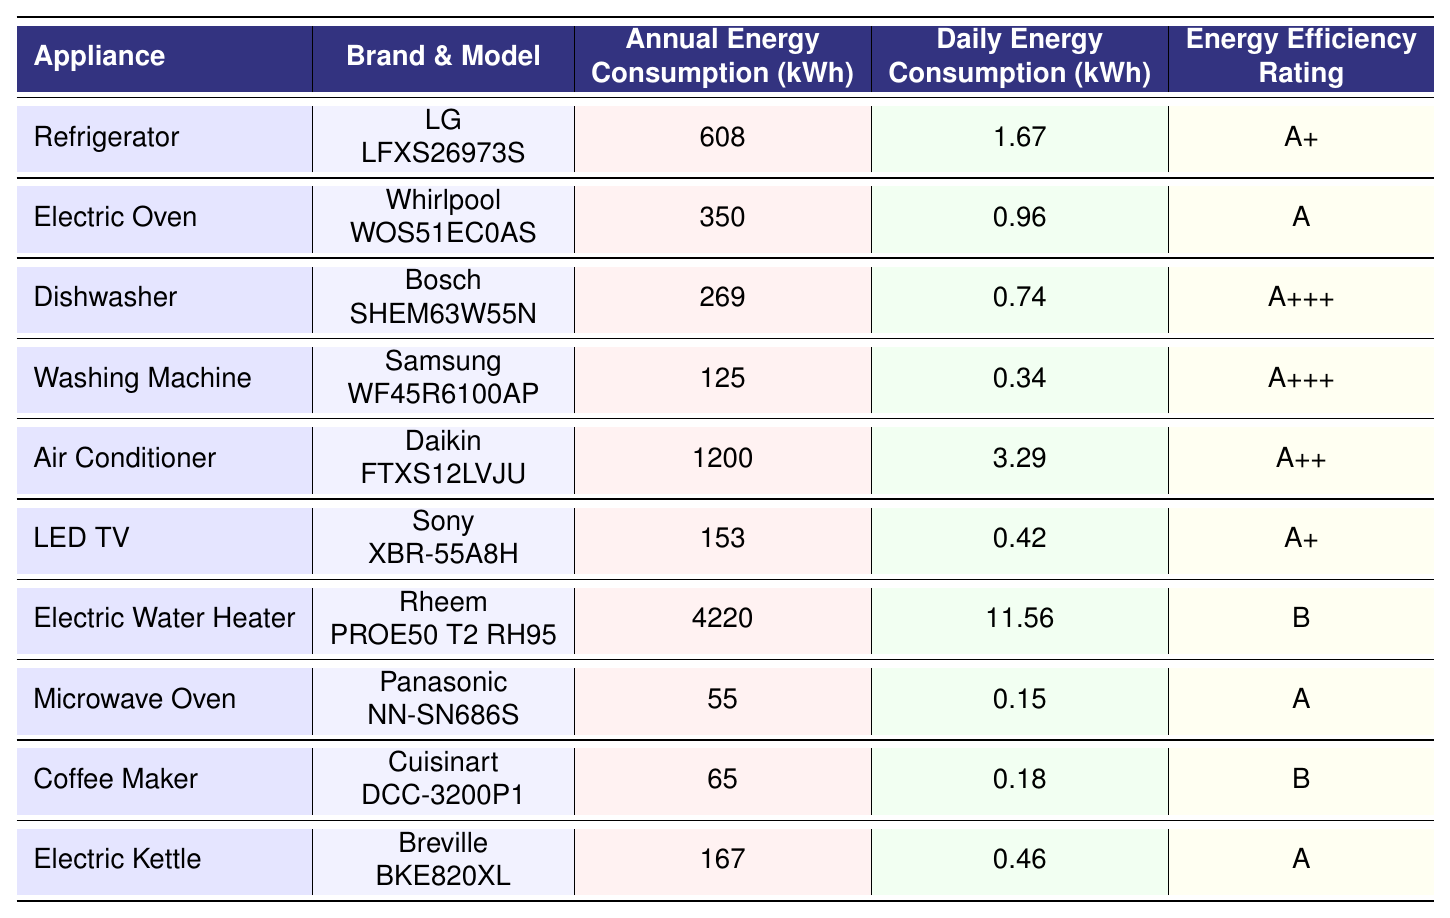What is the annual energy consumption of the Washing Machine? The table lists the Washing Machine with an annual energy consumption of 125 kWh.
Answer: 125 kWh Which appliance has the highest annual energy consumption? By examining the annual energy consumption values, the Electric Water Heater has the highest at 4220 kWh.
Answer: Electric Water Heater What is the daily energy consumption of the LED TV? The daily energy consumption for the LED TV is detailed in the table as 0.42 kWh.
Answer: 0.42 kWh How much more energy does the Air Conditioner consume annually compared to the Dishwasher? The annual consumption of the Air Conditioner is 1200 kWh and the Dishwasher is 269 kWh. The difference is calculated as 1200 - 269 = 931 kWh.
Answer: 931 kWh What is the average daily energy consumption of all appliances listed? To find the average, sum the daily consumptions: (1.67 + 0.96 + 0.74 + 0.34 + 3.29 + 0.42 + 11.56 + 0.15 + 0.18 + 0.46) = 19.37 kWh, then divide by the number of appliances (10): 19.37 / 10 = 1.937 kWh.
Answer: 1.937 kWh Is the Energy Efficiency Rating of the Dishwasher better than that of the Electric Oven? The Dishwasher has an A+++ rating while the Electric Oven has an A rating. Since A+++ is higher than A, the Dishwasher is more efficient.
Answer: Yes Which appliance has the lowest standby power consumption? Checking the standby power values, the Dishwasher has the lowest at 0.5 watts.
Answer: Dishwasher Calculate the total annual energy consumption of all the appliances combined. Adding all annual consumptions: 608 + 350 + 269 + 125 + 1200 + 153 + 4220 + 55 + 65 + 167 = 7517 kWh.
Answer: 7517 kWh Is the daily energy consumption of the Electric Kettle greater than that of the Coffee Maker? The Electric Kettle consumes 0.46 kWh daily while the Coffee Maker consumes 0.18 kWh. Since 0.46 is greater than 0.18, the statement is true.
Answer: Yes What is the difference in annual energy consumption between the Air Conditioner and the Refrigerator? The Air Conditioner consumes 1200 kWh and the Refrigerator consumes 608 kWh. The difference is calculated as 1200 - 608 = 592 kWh.
Answer: 592 kWh 